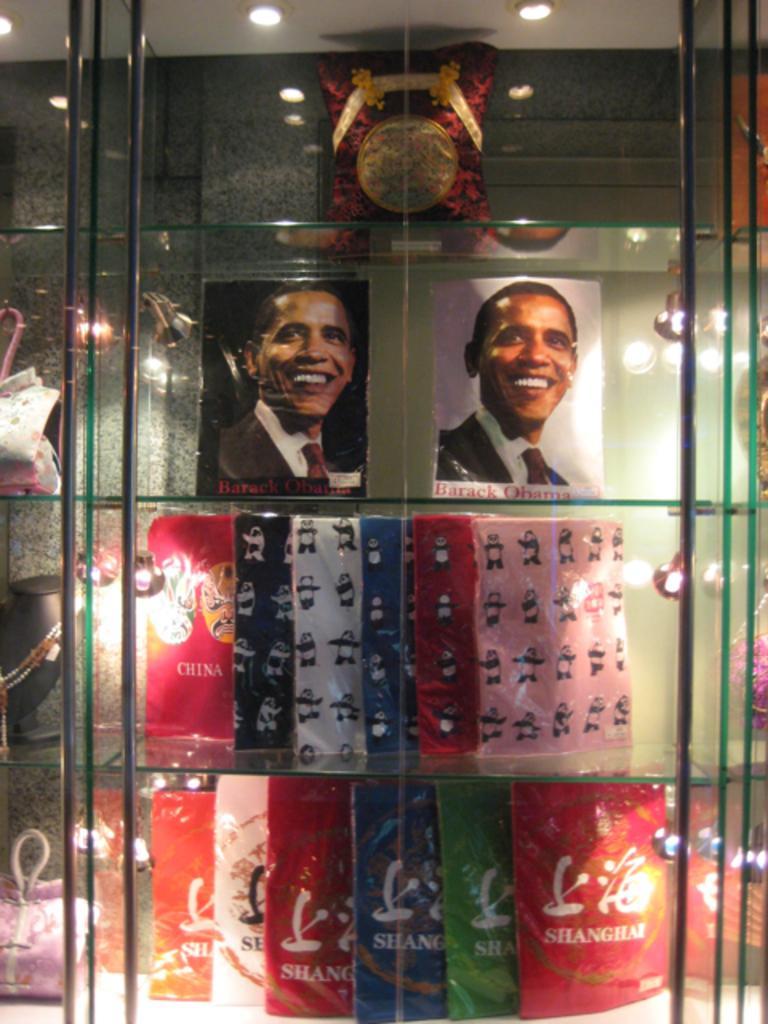How would you summarize this image in a sentence or two? This picture is an inside view of a store. In this picture we can see the boards, bags, chain, pillow in the shelves. At the top of the image we can see the roof and lights. In the background of the image we can see the wall. 